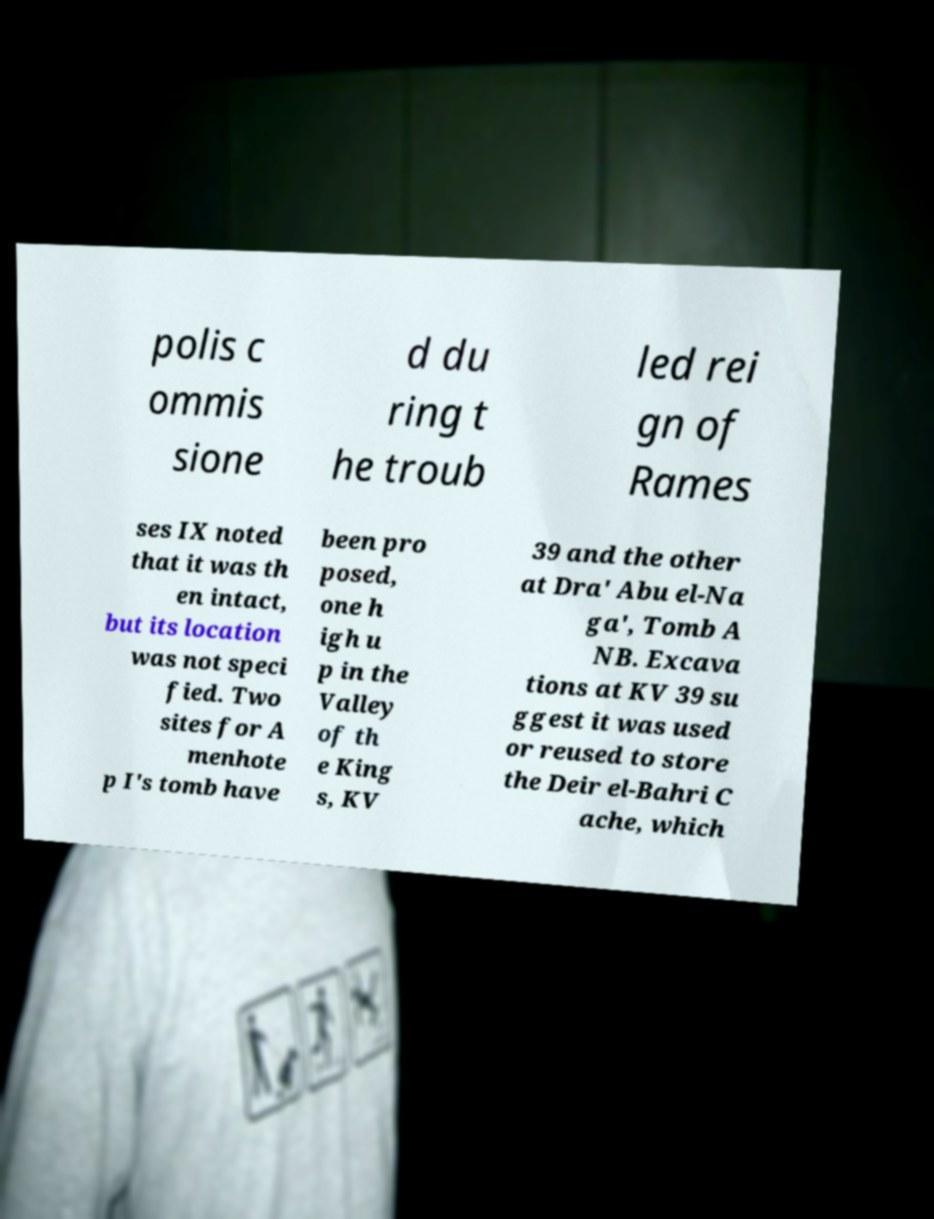I need the written content from this picture converted into text. Can you do that? polis c ommis sione d du ring t he troub led rei gn of Rames ses IX noted that it was th en intact, but its location was not speci fied. Two sites for A menhote p I's tomb have been pro posed, one h igh u p in the Valley of th e King s, KV 39 and the other at Dra' Abu el-Na ga', Tomb A NB. Excava tions at KV 39 su ggest it was used or reused to store the Deir el-Bahri C ache, which 